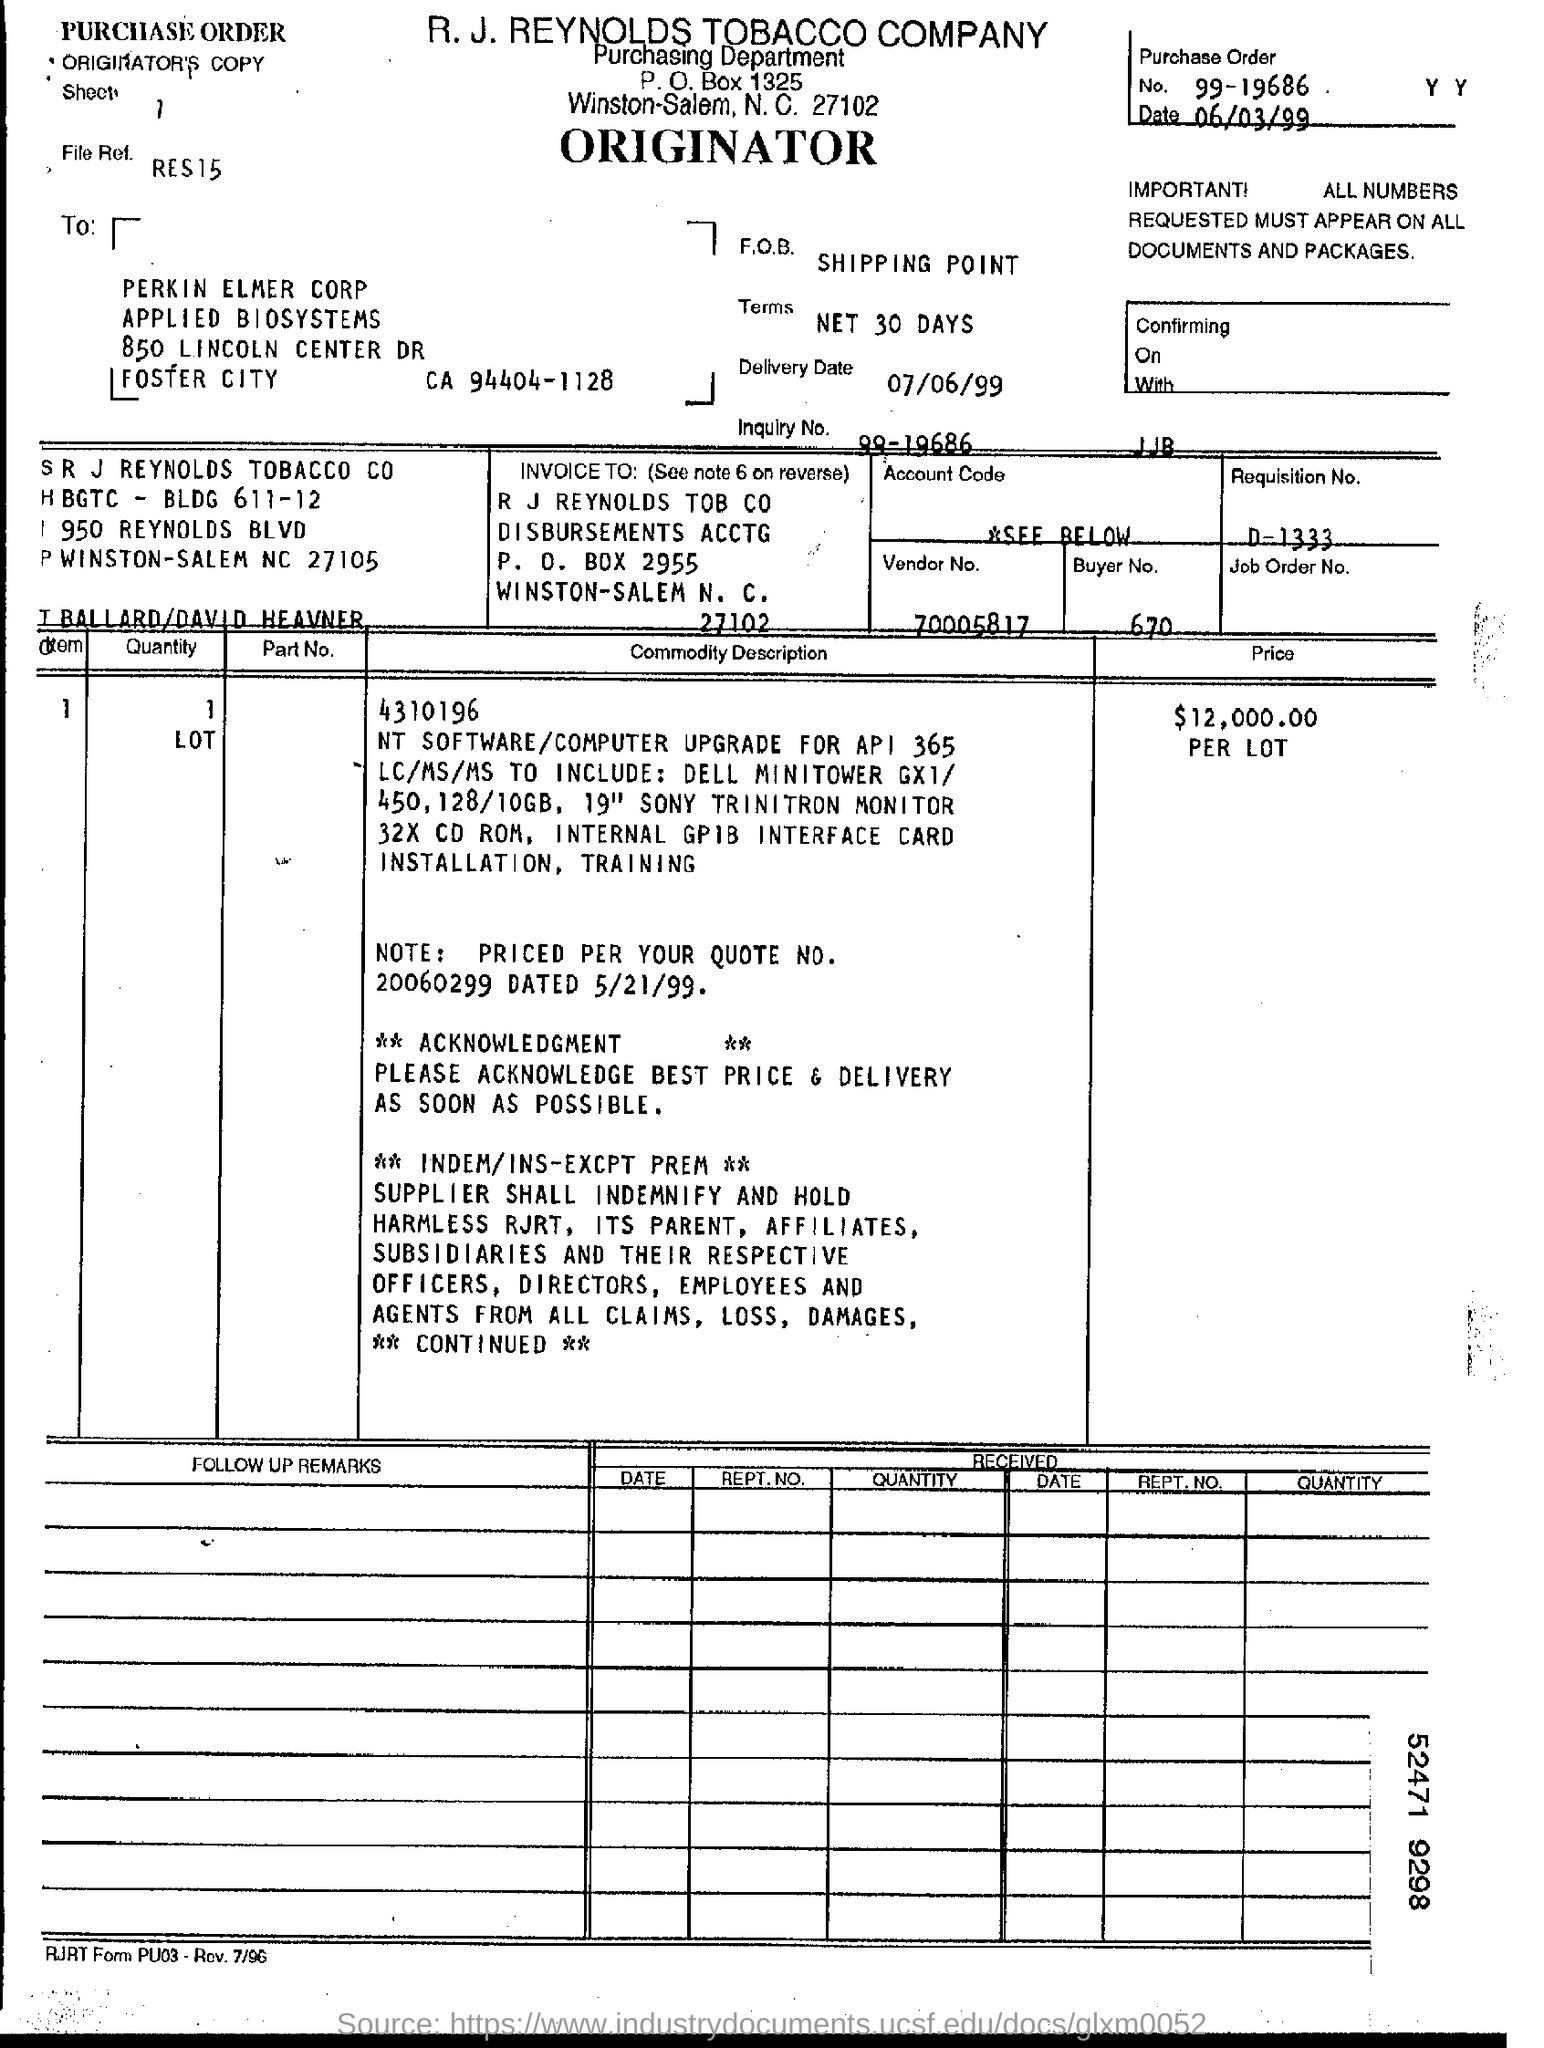What is the number of purchase order?
Ensure brevity in your answer.  99-19686. What is the vendor number?
Your answer should be compact. 70005817. What is the buyer number?
Your response must be concise. 670. 